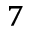<formula> <loc_0><loc_0><loc_500><loc_500>^ { 7 }</formula> 